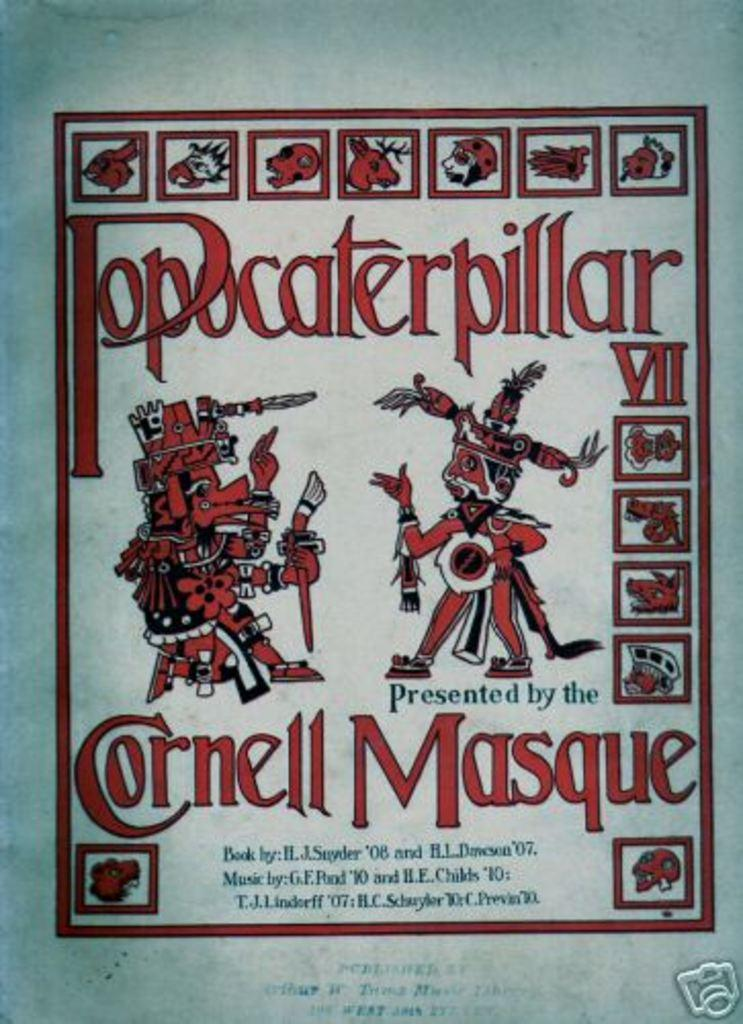<image>
Share a concise interpretation of the image provided. A red poster for Popocaterpillar VII featuring two Indians wearing tribal costumes. 